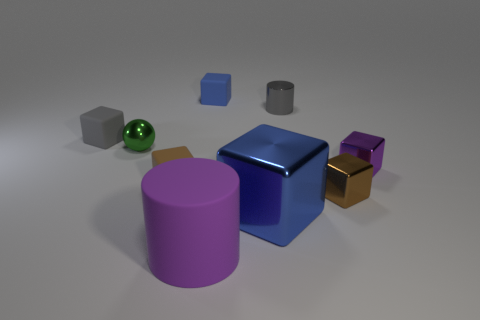Subtract 1 blocks. How many blocks are left? 5 Subtract all purple shiny cubes. How many cubes are left? 5 Subtract all purple blocks. How many blocks are left? 5 Subtract all gray cubes. Subtract all blue spheres. How many cubes are left? 5 Add 1 small gray metal blocks. How many objects exist? 10 Subtract all cylinders. How many objects are left? 7 Add 1 tiny brown shiny objects. How many tiny brown shiny objects are left? 2 Add 8 small cyan spheres. How many small cyan spheres exist? 8 Subtract 0 blue spheres. How many objects are left? 9 Subtract all tiny green balls. Subtract all small purple blocks. How many objects are left? 7 